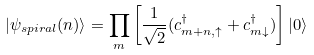<formula> <loc_0><loc_0><loc_500><loc_500>| \psi _ { s p i r a l } ( n ) \rangle = \prod _ { m } \left [ \frac { 1 } { \sqrt { 2 } } ( c ^ { \dagger } _ { m + n , \uparrow } + c ^ { \dagger } _ { m \downarrow } ) \right ] | 0 \rangle</formula> 